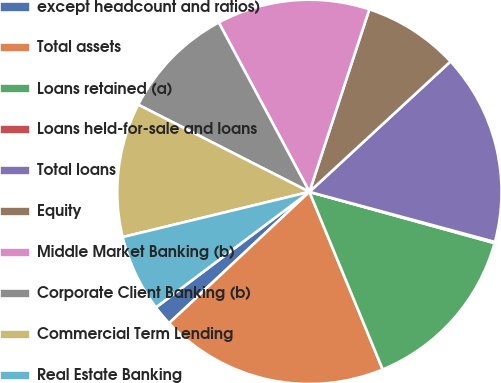Convert chart to OTSL. <chart><loc_0><loc_0><loc_500><loc_500><pie_chart><fcel>except headcount and ratios)<fcel>Total assets<fcel>Loans retained (a)<fcel>Loans held-for-sale and loans<fcel>Total loans<fcel>Equity<fcel>Middle Market Banking (b)<fcel>Corporate Client Banking (b)<fcel>Commercial Term Lending<fcel>Real Estate Banking<nl><fcel>1.7%<fcel>19.26%<fcel>14.47%<fcel>0.1%<fcel>16.07%<fcel>8.08%<fcel>12.87%<fcel>9.68%<fcel>11.28%<fcel>6.49%<nl></chart> 